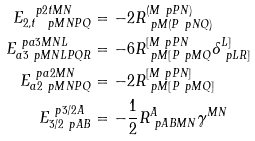<formula> <loc_0><loc_0><loc_500><loc_500>E ^ { \ p { 2 t } M N } _ { { 2 , t } \ p { M N } P Q } & = - 2 R ^ { ( M \ p { P } N ) } _ { \ p { M } ( P \ p { N } Q ) } \\ E ^ { \ p { a 3 } M N L } _ { a 3 \ p { M N L } P Q R } & = - 6 R ^ { [ M \ p { P } N } _ { \ p { M } [ P \ p { M } Q } \delta ^ { L ] } _ { \ p { L } R ] } \\ E ^ { \ p { a 2 } M N } _ { a 2 \ p { M N } P Q } & = - 2 R ^ { [ M \ p { P } N ] } _ { \ p { M } [ P \ p { M } Q ] } \\ E _ { 3 / 2 \ p A B } ^ { \ p { 3 / 2 } A } & = - \frac { 1 } { 2 } R ^ { A } _ { \ p A B M N } \gamma ^ { M N }</formula> 